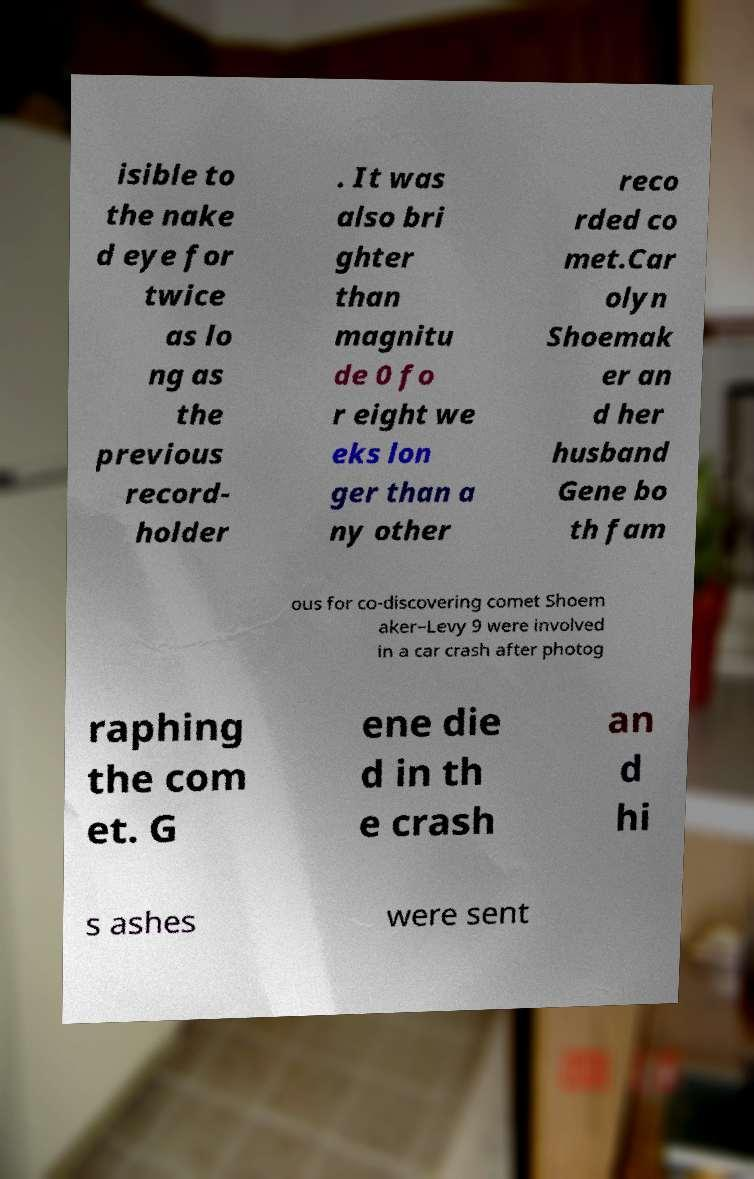Please read and relay the text visible in this image. What does it say? isible to the nake d eye for twice as lo ng as the previous record- holder . It was also bri ghter than magnitu de 0 fo r eight we eks lon ger than a ny other reco rded co met.Car olyn Shoemak er an d her husband Gene bo th fam ous for co-discovering comet Shoem aker–Levy 9 were involved in a car crash after photog raphing the com et. G ene die d in th e crash an d hi s ashes were sent 